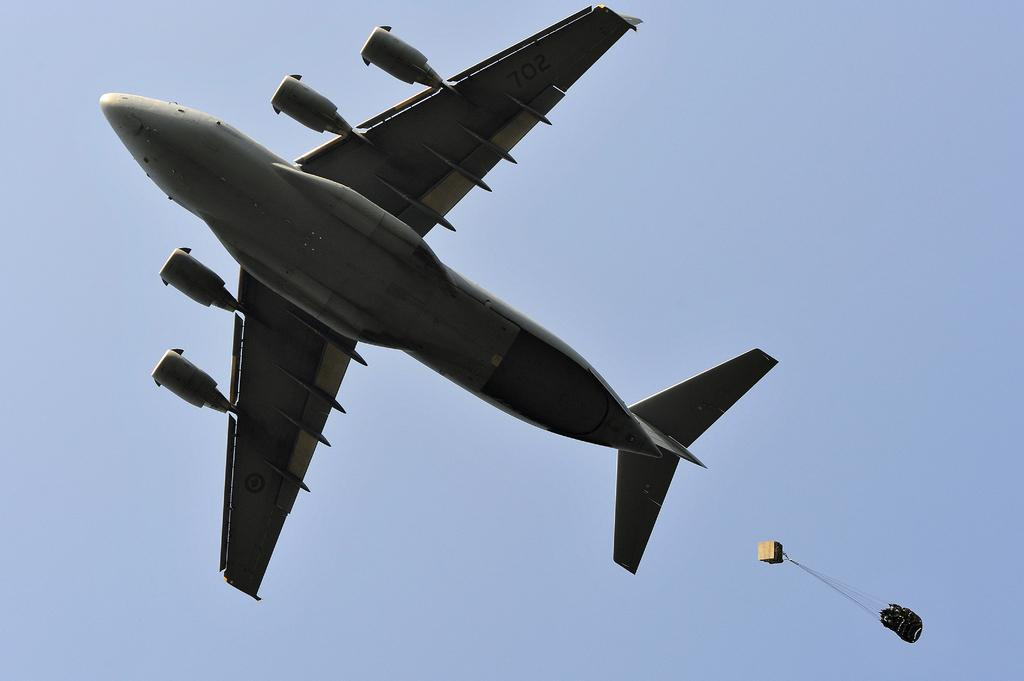What is the main subject of the image? The main subject of the image is an airplane. What is the airplane doing in the image? The airplane is flying in the air. What object can be seen in the bottom right-hand corner of the image? There is a parachute in the bottom right-hand corner of the image. What can be seen in the background of the image? The sky is visible in the background of the image. What is the color of the sky in the image? The color of the sky is blue. What type of memory is being used by the airplane in the image? There is no mention of memory being used by the airplane in the image. What cord is attached to the parachute in the image? There is no visible cord attached to the parachute in the image. 